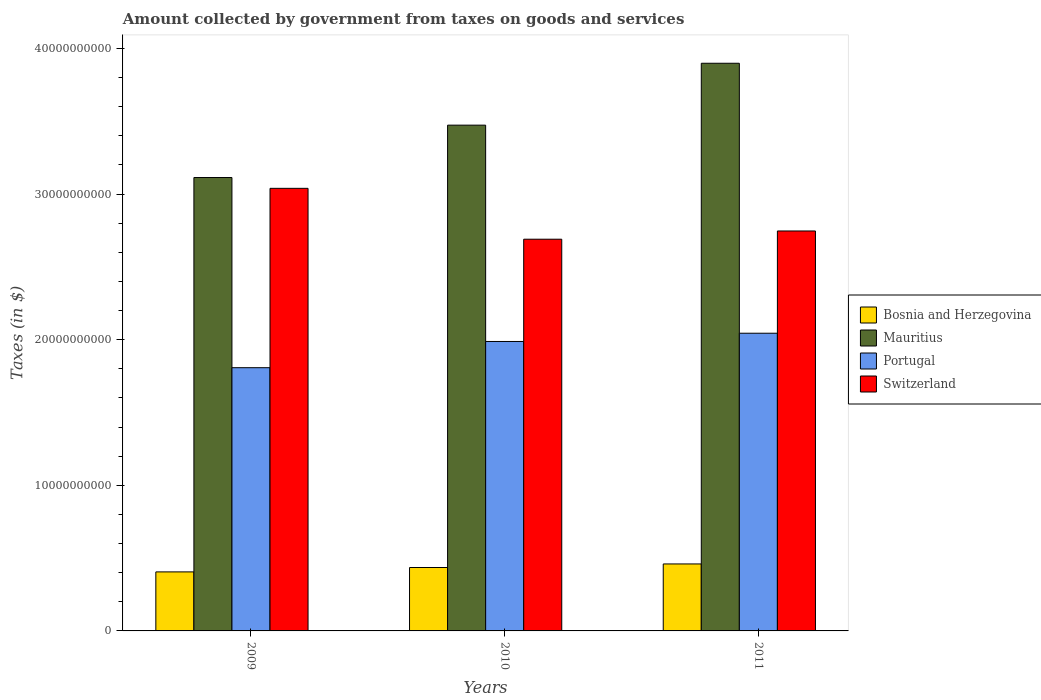How many different coloured bars are there?
Keep it short and to the point. 4. Are the number of bars per tick equal to the number of legend labels?
Ensure brevity in your answer.  Yes. Are the number of bars on each tick of the X-axis equal?
Offer a terse response. Yes. How many bars are there on the 2nd tick from the right?
Provide a short and direct response. 4. What is the amount collected by government from taxes on goods and services in Mauritius in 2011?
Offer a terse response. 3.90e+1. Across all years, what is the maximum amount collected by government from taxes on goods and services in Portugal?
Keep it short and to the point. 2.04e+1. Across all years, what is the minimum amount collected by government from taxes on goods and services in Bosnia and Herzegovina?
Your answer should be very brief. 4.05e+09. In which year was the amount collected by government from taxes on goods and services in Portugal maximum?
Provide a short and direct response. 2011. In which year was the amount collected by government from taxes on goods and services in Portugal minimum?
Provide a succinct answer. 2009. What is the total amount collected by government from taxes on goods and services in Mauritius in the graph?
Your response must be concise. 1.05e+11. What is the difference between the amount collected by government from taxes on goods and services in Bosnia and Herzegovina in 2009 and that in 2011?
Your answer should be compact. -5.46e+08. What is the difference between the amount collected by government from taxes on goods and services in Switzerland in 2011 and the amount collected by government from taxes on goods and services in Bosnia and Herzegovina in 2009?
Offer a terse response. 2.34e+1. What is the average amount collected by government from taxes on goods and services in Portugal per year?
Give a very brief answer. 1.95e+1. In the year 2009, what is the difference between the amount collected by government from taxes on goods and services in Bosnia and Herzegovina and amount collected by government from taxes on goods and services in Mauritius?
Offer a very short reply. -2.71e+1. In how many years, is the amount collected by government from taxes on goods and services in Switzerland greater than 8000000000 $?
Offer a very short reply. 3. What is the ratio of the amount collected by government from taxes on goods and services in Switzerland in 2009 to that in 2010?
Make the answer very short. 1.13. Is the amount collected by government from taxes on goods and services in Portugal in 2010 less than that in 2011?
Your answer should be very brief. Yes. What is the difference between the highest and the second highest amount collected by government from taxes on goods and services in Portugal?
Offer a terse response. 5.66e+08. What is the difference between the highest and the lowest amount collected by government from taxes on goods and services in Switzerland?
Provide a succinct answer. 3.49e+09. Is the sum of the amount collected by government from taxes on goods and services in Switzerland in 2009 and 2010 greater than the maximum amount collected by government from taxes on goods and services in Portugal across all years?
Offer a terse response. Yes. Is it the case that in every year, the sum of the amount collected by government from taxes on goods and services in Portugal and amount collected by government from taxes on goods and services in Switzerland is greater than the sum of amount collected by government from taxes on goods and services in Mauritius and amount collected by government from taxes on goods and services in Bosnia and Herzegovina?
Make the answer very short. No. What does the 3rd bar from the left in 2009 represents?
Offer a very short reply. Portugal. What does the 3rd bar from the right in 2009 represents?
Offer a very short reply. Mauritius. Are all the bars in the graph horizontal?
Offer a terse response. No. How many years are there in the graph?
Offer a terse response. 3. What is the difference between two consecutive major ticks on the Y-axis?
Your response must be concise. 1.00e+1. Are the values on the major ticks of Y-axis written in scientific E-notation?
Keep it short and to the point. No. Does the graph contain any zero values?
Keep it short and to the point. No. Does the graph contain grids?
Offer a very short reply. No. Where does the legend appear in the graph?
Give a very brief answer. Center right. How many legend labels are there?
Keep it short and to the point. 4. How are the legend labels stacked?
Your response must be concise. Vertical. What is the title of the graph?
Your response must be concise. Amount collected by government from taxes on goods and services. What is the label or title of the X-axis?
Give a very brief answer. Years. What is the label or title of the Y-axis?
Keep it short and to the point. Taxes (in $). What is the Taxes (in $) in Bosnia and Herzegovina in 2009?
Offer a very short reply. 4.05e+09. What is the Taxes (in $) in Mauritius in 2009?
Give a very brief answer. 3.11e+1. What is the Taxes (in $) in Portugal in 2009?
Provide a short and direct response. 1.81e+1. What is the Taxes (in $) of Switzerland in 2009?
Give a very brief answer. 3.04e+1. What is the Taxes (in $) in Bosnia and Herzegovina in 2010?
Offer a terse response. 4.35e+09. What is the Taxes (in $) of Mauritius in 2010?
Your response must be concise. 3.47e+1. What is the Taxes (in $) of Portugal in 2010?
Give a very brief answer. 1.99e+1. What is the Taxes (in $) of Switzerland in 2010?
Provide a succinct answer. 2.69e+1. What is the Taxes (in $) of Bosnia and Herzegovina in 2011?
Offer a terse response. 4.60e+09. What is the Taxes (in $) in Mauritius in 2011?
Keep it short and to the point. 3.90e+1. What is the Taxes (in $) in Portugal in 2011?
Provide a short and direct response. 2.04e+1. What is the Taxes (in $) in Switzerland in 2011?
Make the answer very short. 2.75e+1. Across all years, what is the maximum Taxes (in $) of Bosnia and Herzegovina?
Make the answer very short. 4.60e+09. Across all years, what is the maximum Taxes (in $) in Mauritius?
Provide a short and direct response. 3.90e+1. Across all years, what is the maximum Taxes (in $) in Portugal?
Ensure brevity in your answer.  2.04e+1. Across all years, what is the maximum Taxes (in $) in Switzerland?
Your answer should be compact. 3.04e+1. Across all years, what is the minimum Taxes (in $) of Bosnia and Herzegovina?
Your answer should be compact. 4.05e+09. Across all years, what is the minimum Taxes (in $) of Mauritius?
Your answer should be compact. 3.11e+1. Across all years, what is the minimum Taxes (in $) of Portugal?
Give a very brief answer. 1.81e+1. Across all years, what is the minimum Taxes (in $) of Switzerland?
Give a very brief answer. 2.69e+1. What is the total Taxes (in $) of Bosnia and Herzegovina in the graph?
Your response must be concise. 1.30e+1. What is the total Taxes (in $) of Mauritius in the graph?
Provide a short and direct response. 1.05e+11. What is the total Taxes (in $) of Portugal in the graph?
Offer a very short reply. 5.84e+1. What is the total Taxes (in $) of Switzerland in the graph?
Offer a terse response. 8.48e+1. What is the difference between the Taxes (in $) of Bosnia and Herzegovina in 2009 and that in 2010?
Your answer should be very brief. -3.02e+08. What is the difference between the Taxes (in $) of Mauritius in 2009 and that in 2010?
Offer a very short reply. -3.60e+09. What is the difference between the Taxes (in $) in Portugal in 2009 and that in 2010?
Make the answer very short. -1.80e+09. What is the difference between the Taxes (in $) of Switzerland in 2009 and that in 2010?
Your answer should be compact. 3.49e+09. What is the difference between the Taxes (in $) in Bosnia and Herzegovina in 2009 and that in 2011?
Your answer should be compact. -5.46e+08. What is the difference between the Taxes (in $) in Mauritius in 2009 and that in 2011?
Your response must be concise. -7.85e+09. What is the difference between the Taxes (in $) of Portugal in 2009 and that in 2011?
Provide a succinct answer. -2.37e+09. What is the difference between the Taxes (in $) in Switzerland in 2009 and that in 2011?
Offer a terse response. 2.93e+09. What is the difference between the Taxes (in $) of Bosnia and Herzegovina in 2010 and that in 2011?
Your answer should be very brief. -2.44e+08. What is the difference between the Taxes (in $) in Mauritius in 2010 and that in 2011?
Provide a succinct answer. -4.25e+09. What is the difference between the Taxes (in $) of Portugal in 2010 and that in 2011?
Your answer should be very brief. -5.66e+08. What is the difference between the Taxes (in $) of Switzerland in 2010 and that in 2011?
Offer a terse response. -5.66e+08. What is the difference between the Taxes (in $) in Bosnia and Herzegovina in 2009 and the Taxes (in $) in Mauritius in 2010?
Ensure brevity in your answer.  -3.07e+1. What is the difference between the Taxes (in $) in Bosnia and Herzegovina in 2009 and the Taxes (in $) in Portugal in 2010?
Your answer should be compact. -1.58e+1. What is the difference between the Taxes (in $) in Bosnia and Herzegovina in 2009 and the Taxes (in $) in Switzerland in 2010?
Keep it short and to the point. -2.28e+1. What is the difference between the Taxes (in $) of Mauritius in 2009 and the Taxes (in $) of Portugal in 2010?
Provide a succinct answer. 1.13e+1. What is the difference between the Taxes (in $) of Mauritius in 2009 and the Taxes (in $) of Switzerland in 2010?
Offer a very short reply. 4.24e+09. What is the difference between the Taxes (in $) of Portugal in 2009 and the Taxes (in $) of Switzerland in 2010?
Provide a succinct answer. -8.82e+09. What is the difference between the Taxes (in $) in Bosnia and Herzegovina in 2009 and the Taxes (in $) in Mauritius in 2011?
Your response must be concise. -3.49e+1. What is the difference between the Taxes (in $) in Bosnia and Herzegovina in 2009 and the Taxes (in $) in Portugal in 2011?
Offer a very short reply. -1.64e+1. What is the difference between the Taxes (in $) of Bosnia and Herzegovina in 2009 and the Taxes (in $) of Switzerland in 2011?
Ensure brevity in your answer.  -2.34e+1. What is the difference between the Taxes (in $) of Mauritius in 2009 and the Taxes (in $) of Portugal in 2011?
Offer a very short reply. 1.07e+1. What is the difference between the Taxes (in $) in Mauritius in 2009 and the Taxes (in $) in Switzerland in 2011?
Your answer should be compact. 3.67e+09. What is the difference between the Taxes (in $) of Portugal in 2009 and the Taxes (in $) of Switzerland in 2011?
Provide a succinct answer. -9.39e+09. What is the difference between the Taxes (in $) in Bosnia and Herzegovina in 2010 and the Taxes (in $) in Mauritius in 2011?
Make the answer very short. -3.46e+1. What is the difference between the Taxes (in $) in Bosnia and Herzegovina in 2010 and the Taxes (in $) in Portugal in 2011?
Offer a very short reply. -1.61e+1. What is the difference between the Taxes (in $) of Bosnia and Herzegovina in 2010 and the Taxes (in $) of Switzerland in 2011?
Keep it short and to the point. -2.31e+1. What is the difference between the Taxes (in $) of Mauritius in 2010 and the Taxes (in $) of Portugal in 2011?
Offer a terse response. 1.43e+1. What is the difference between the Taxes (in $) of Mauritius in 2010 and the Taxes (in $) of Switzerland in 2011?
Give a very brief answer. 7.27e+09. What is the difference between the Taxes (in $) in Portugal in 2010 and the Taxes (in $) in Switzerland in 2011?
Ensure brevity in your answer.  -7.59e+09. What is the average Taxes (in $) in Bosnia and Herzegovina per year?
Keep it short and to the point. 4.34e+09. What is the average Taxes (in $) in Mauritius per year?
Your response must be concise. 3.50e+1. What is the average Taxes (in $) of Portugal per year?
Give a very brief answer. 1.95e+1. What is the average Taxes (in $) in Switzerland per year?
Make the answer very short. 2.83e+1. In the year 2009, what is the difference between the Taxes (in $) in Bosnia and Herzegovina and Taxes (in $) in Mauritius?
Give a very brief answer. -2.71e+1. In the year 2009, what is the difference between the Taxes (in $) of Bosnia and Herzegovina and Taxes (in $) of Portugal?
Make the answer very short. -1.40e+1. In the year 2009, what is the difference between the Taxes (in $) in Bosnia and Herzegovina and Taxes (in $) in Switzerland?
Your response must be concise. -2.63e+1. In the year 2009, what is the difference between the Taxes (in $) in Mauritius and Taxes (in $) in Portugal?
Provide a short and direct response. 1.31e+1. In the year 2009, what is the difference between the Taxes (in $) in Mauritius and Taxes (in $) in Switzerland?
Keep it short and to the point. 7.43e+08. In the year 2009, what is the difference between the Taxes (in $) in Portugal and Taxes (in $) in Switzerland?
Keep it short and to the point. -1.23e+1. In the year 2010, what is the difference between the Taxes (in $) of Bosnia and Herzegovina and Taxes (in $) of Mauritius?
Provide a short and direct response. -3.04e+1. In the year 2010, what is the difference between the Taxes (in $) in Bosnia and Herzegovina and Taxes (in $) in Portugal?
Your answer should be compact. -1.55e+1. In the year 2010, what is the difference between the Taxes (in $) of Bosnia and Herzegovina and Taxes (in $) of Switzerland?
Give a very brief answer. -2.25e+1. In the year 2010, what is the difference between the Taxes (in $) in Mauritius and Taxes (in $) in Portugal?
Offer a terse response. 1.49e+1. In the year 2010, what is the difference between the Taxes (in $) in Mauritius and Taxes (in $) in Switzerland?
Provide a short and direct response. 7.83e+09. In the year 2010, what is the difference between the Taxes (in $) of Portugal and Taxes (in $) of Switzerland?
Your response must be concise. -7.02e+09. In the year 2011, what is the difference between the Taxes (in $) of Bosnia and Herzegovina and Taxes (in $) of Mauritius?
Offer a very short reply. -3.44e+1. In the year 2011, what is the difference between the Taxes (in $) in Bosnia and Herzegovina and Taxes (in $) in Portugal?
Provide a succinct answer. -1.58e+1. In the year 2011, what is the difference between the Taxes (in $) of Bosnia and Herzegovina and Taxes (in $) of Switzerland?
Keep it short and to the point. -2.29e+1. In the year 2011, what is the difference between the Taxes (in $) of Mauritius and Taxes (in $) of Portugal?
Your response must be concise. 1.85e+1. In the year 2011, what is the difference between the Taxes (in $) of Mauritius and Taxes (in $) of Switzerland?
Provide a succinct answer. 1.15e+1. In the year 2011, what is the difference between the Taxes (in $) of Portugal and Taxes (in $) of Switzerland?
Make the answer very short. -7.02e+09. What is the ratio of the Taxes (in $) in Bosnia and Herzegovina in 2009 to that in 2010?
Your response must be concise. 0.93. What is the ratio of the Taxes (in $) of Mauritius in 2009 to that in 2010?
Provide a succinct answer. 0.9. What is the ratio of the Taxes (in $) of Portugal in 2009 to that in 2010?
Your answer should be very brief. 0.91. What is the ratio of the Taxes (in $) in Switzerland in 2009 to that in 2010?
Keep it short and to the point. 1.13. What is the ratio of the Taxes (in $) of Bosnia and Herzegovina in 2009 to that in 2011?
Make the answer very short. 0.88. What is the ratio of the Taxes (in $) of Mauritius in 2009 to that in 2011?
Make the answer very short. 0.8. What is the ratio of the Taxes (in $) of Portugal in 2009 to that in 2011?
Your answer should be compact. 0.88. What is the ratio of the Taxes (in $) of Switzerland in 2009 to that in 2011?
Keep it short and to the point. 1.11. What is the ratio of the Taxes (in $) in Bosnia and Herzegovina in 2010 to that in 2011?
Make the answer very short. 0.95. What is the ratio of the Taxes (in $) in Mauritius in 2010 to that in 2011?
Your response must be concise. 0.89. What is the ratio of the Taxes (in $) in Portugal in 2010 to that in 2011?
Give a very brief answer. 0.97. What is the ratio of the Taxes (in $) of Switzerland in 2010 to that in 2011?
Your answer should be compact. 0.98. What is the difference between the highest and the second highest Taxes (in $) of Bosnia and Herzegovina?
Ensure brevity in your answer.  2.44e+08. What is the difference between the highest and the second highest Taxes (in $) in Mauritius?
Give a very brief answer. 4.25e+09. What is the difference between the highest and the second highest Taxes (in $) of Portugal?
Offer a terse response. 5.66e+08. What is the difference between the highest and the second highest Taxes (in $) in Switzerland?
Give a very brief answer. 2.93e+09. What is the difference between the highest and the lowest Taxes (in $) of Bosnia and Herzegovina?
Offer a very short reply. 5.46e+08. What is the difference between the highest and the lowest Taxes (in $) in Mauritius?
Ensure brevity in your answer.  7.85e+09. What is the difference between the highest and the lowest Taxes (in $) of Portugal?
Make the answer very short. 2.37e+09. What is the difference between the highest and the lowest Taxes (in $) of Switzerland?
Give a very brief answer. 3.49e+09. 